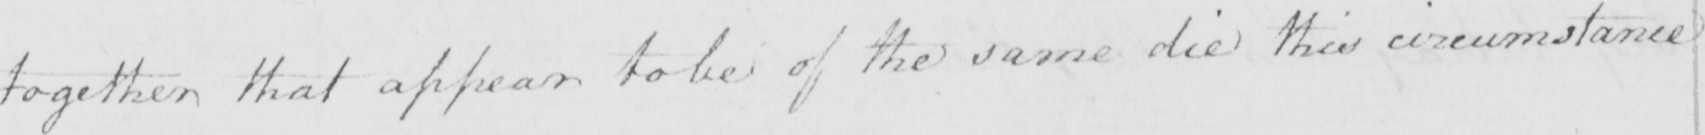Can you read and transcribe this handwriting? together that appear to be of the same die this circumstance 